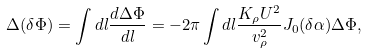<formula> <loc_0><loc_0><loc_500><loc_500>\Delta ( \delta \Phi ) = \int d l \frac { d \Delta \Phi } { d l } = - 2 \pi \int d l \frac { K _ { \rho } U ^ { 2 } } { v _ { \rho } ^ { 2 } } J _ { 0 } ( \delta \alpha ) \Delta \Phi ,</formula> 